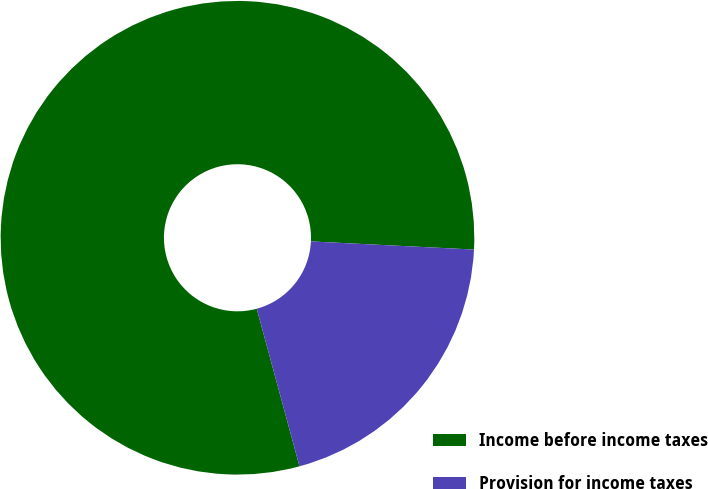<chart> <loc_0><loc_0><loc_500><loc_500><pie_chart><fcel>Income before income taxes<fcel>Provision for income taxes<nl><fcel>80.01%<fcel>19.99%<nl></chart> 